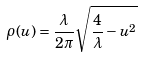<formula> <loc_0><loc_0><loc_500><loc_500>\rho ( u ) = \frac { \lambda } { 2 \pi } \sqrt { \frac { 4 } { \lambda } - u ^ { 2 } }</formula> 